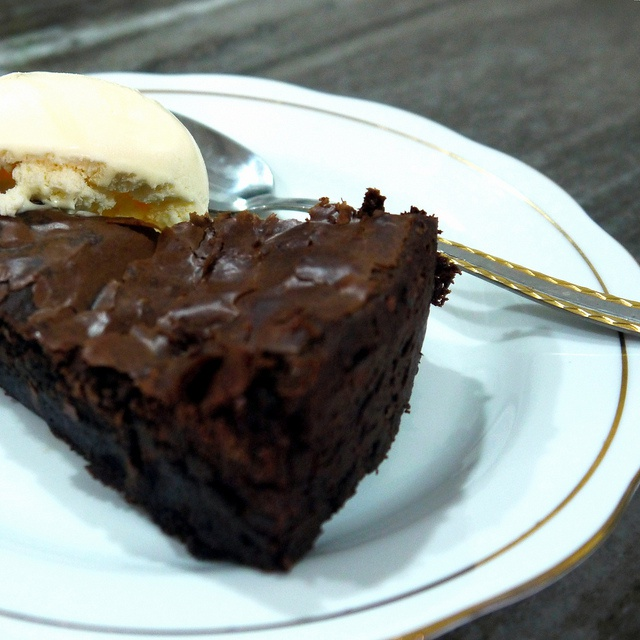Describe the objects in this image and their specific colors. I can see cake in black, maroon, and gray tones, cake in black, beige, tan, and olive tones, fork in black, gray, white, and darkgray tones, and spoon in black, gray, darkgray, and white tones in this image. 